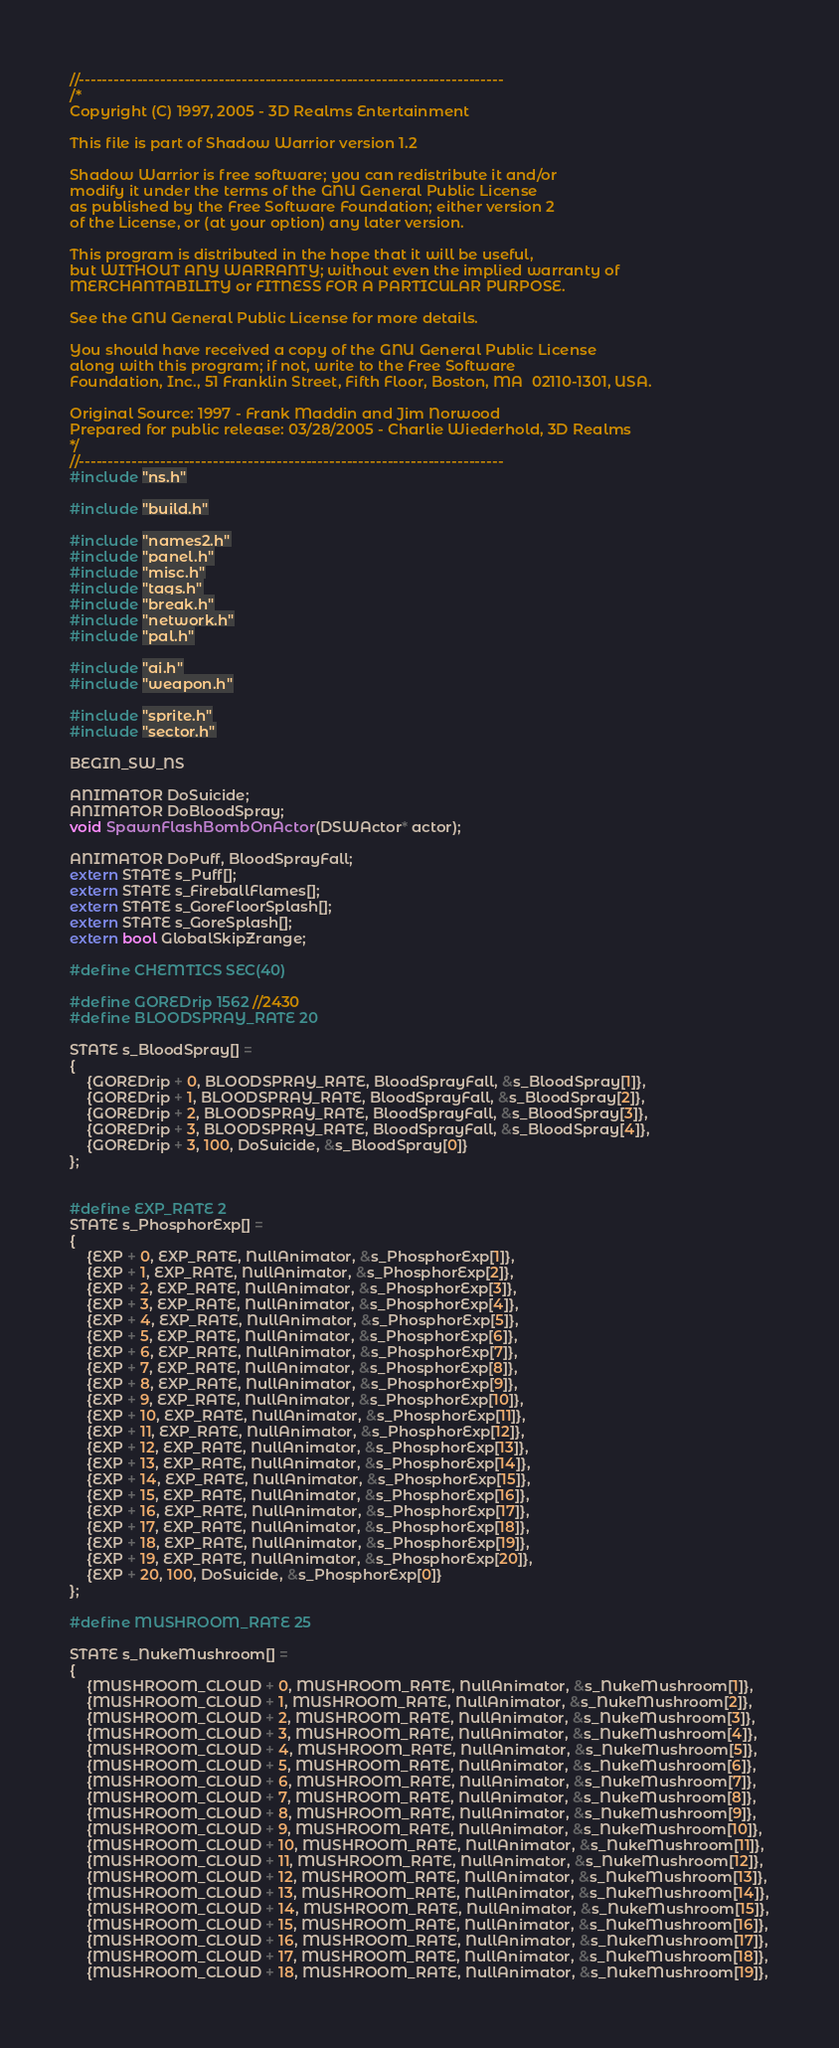<code> <loc_0><loc_0><loc_500><loc_500><_C++_>//-------------------------------------------------------------------------
/*
Copyright (C) 1997, 2005 - 3D Realms Entertainment

This file is part of Shadow Warrior version 1.2

Shadow Warrior is free software; you can redistribute it and/or
modify it under the terms of the GNU General Public License
as published by the Free Software Foundation; either version 2
of the License, or (at your option) any later version.

This program is distributed in the hope that it will be useful,
but WITHOUT ANY WARRANTY; without even the implied warranty of
MERCHANTABILITY or FITNESS FOR A PARTICULAR PURPOSE.

See the GNU General Public License for more details.

You should have received a copy of the GNU General Public License
along with this program; if not, write to the Free Software
Foundation, Inc., 51 Franklin Street, Fifth Floor, Boston, MA  02110-1301, USA.

Original Source: 1997 - Frank Maddin and Jim Norwood
Prepared for public release: 03/28/2005 - Charlie Wiederhold, 3D Realms
*/
//-------------------------------------------------------------------------
#include "ns.h"

#include "build.h"

#include "names2.h"
#include "panel.h"
#include "misc.h"
#include "tags.h"
#include "break.h"
#include "network.h"
#include "pal.h"

#include "ai.h"
#include "weapon.h"

#include "sprite.h"
#include "sector.h"

BEGIN_SW_NS

ANIMATOR DoSuicide;
ANIMATOR DoBloodSpray;
void SpawnFlashBombOnActor(DSWActor* actor);

ANIMATOR DoPuff, BloodSprayFall;
extern STATE s_Puff[];
extern STATE s_FireballFlames[];
extern STATE s_GoreFloorSplash[];
extern STATE s_GoreSplash[];
extern bool GlobalSkipZrange;

#define CHEMTICS SEC(40)

#define GOREDrip 1562 //2430
#define BLOODSPRAY_RATE 20

STATE s_BloodSpray[] =
{
    {GOREDrip + 0, BLOODSPRAY_RATE, BloodSprayFall, &s_BloodSpray[1]},
    {GOREDrip + 1, BLOODSPRAY_RATE, BloodSprayFall, &s_BloodSpray[2]},
    {GOREDrip + 2, BLOODSPRAY_RATE, BloodSprayFall, &s_BloodSpray[3]},
    {GOREDrip + 3, BLOODSPRAY_RATE, BloodSprayFall, &s_BloodSpray[4]},
    {GOREDrip + 3, 100, DoSuicide, &s_BloodSpray[0]}
};


#define EXP_RATE 2
STATE s_PhosphorExp[] =
{
    {EXP + 0, EXP_RATE, NullAnimator, &s_PhosphorExp[1]},
    {EXP + 1, EXP_RATE, NullAnimator, &s_PhosphorExp[2]},
    {EXP + 2, EXP_RATE, NullAnimator, &s_PhosphorExp[3]},
    {EXP + 3, EXP_RATE, NullAnimator, &s_PhosphorExp[4]},
    {EXP + 4, EXP_RATE, NullAnimator, &s_PhosphorExp[5]},
    {EXP + 5, EXP_RATE, NullAnimator, &s_PhosphorExp[6]},
    {EXP + 6, EXP_RATE, NullAnimator, &s_PhosphorExp[7]},
    {EXP + 7, EXP_RATE, NullAnimator, &s_PhosphorExp[8]},
    {EXP + 8, EXP_RATE, NullAnimator, &s_PhosphorExp[9]},
    {EXP + 9, EXP_RATE, NullAnimator, &s_PhosphorExp[10]},
    {EXP + 10, EXP_RATE, NullAnimator, &s_PhosphorExp[11]},
    {EXP + 11, EXP_RATE, NullAnimator, &s_PhosphorExp[12]},
    {EXP + 12, EXP_RATE, NullAnimator, &s_PhosphorExp[13]},
    {EXP + 13, EXP_RATE, NullAnimator, &s_PhosphorExp[14]},
    {EXP + 14, EXP_RATE, NullAnimator, &s_PhosphorExp[15]},
    {EXP + 15, EXP_RATE, NullAnimator, &s_PhosphorExp[16]},
    {EXP + 16, EXP_RATE, NullAnimator, &s_PhosphorExp[17]},
    {EXP + 17, EXP_RATE, NullAnimator, &s_PhosphorExp[18]},
    {EXP + 18, EXP_RATE, NullAnimator, &s_PhosphorExp[19]},
    {EXP + 19, EXP_RATE, NullAnimator, &s_PhosphorExp[20]},
    {EXP + 20, 100, DoSuicide, &s_PhosphorExp[0]}
};

#define MUSHROOM_RATE 25

STATE s_NukeMushroom[] =
{
    {MUSHROOM_CLOUD + 0, MUSHROOM_RATE, NullAnimator, &s_NukeMushroom[1]},
    {MUSHROOM_CLOUD + 1, MUSHROOM_RATE, NullAnimator, &s_NukeMushroom[2]},
    {MUSHROOM_CLOUD + 2, MUSHROOM_RATE, NullAnimator, &s_NukeMushroom[3]},
    {MUSHROOM_CLOUD + 3, MUSHROOM_RATE, NullAnimator, &s_NukeMushroom[4]},
    {MUSHROOM_CLOUD + 4, MUSHROOM_RATE, NullAnimator, &s_NukeMushroom[5]},
    {MUSHROOM_CLOUD + 5, MUSHROOM_RATE, NullAnimator, &s_NukeMushroom[6]},
    {MUSHROOM_CLOUD + 6, MUSHROOM_RATE, NullAnimator, &s_NukeMushroom[7]},
    {MUSHROOM_CLOUD + 7, MUSHROOM_RATE, NullAnimator, &s_NukeMushroom[8]},
    {MUSHROOM_CLOUD + 8, MUSHROOM_RATE, NullAnimator, &s_NukeMushroom[9]},
    {MUSHROOM_CLOUD + 9, MUSHROOM_RATE, NullAnimator, &s_NukeMushroom[10]},
    {MUSHROOM_CLOUD + 10, MUSHROOM_RATE, NullAnimator, &s_NukeMushroom[11]},
    {MUSHROOM_CLOUD + 11, MUSHROOM_RATE, NullAnimator, &s_NukeMushroom[12]},
    {MUSHROOM_CLOUD + 12, MUSHROOM_RATE, NullAnimator, &s_NukeMushroom[13]},
    {MUSHROOM_CLOUD + 13, MUSHROOM_RATE, NullAnimator, &s_NukeMushroom[14]},
    {MUSHROOM_CLOUD + 14, MUSHROOM_RATE, NullAnimator, &s_NukeMushroom[15]},
    {MUSHROOM_CLOUD + 15, MUSHROOM_RATE, NullAnimator, &s_NukeMushroom[16]},
    {MUSHROOM_CLOUD + 16, MUSHROOM_RATE, NullAnimator, &s_NukeMushroom[17]},
    {MUSHROOM_CLOUD + 17, MUSHROOM_RATE, NullAnimator, &s_NukeMushroom[18]},
    {MUSHROOM_CLOUD + 18, MUSHROOM_RATE, NullAnimator, &s_NukeMushroom[19]},</code> 